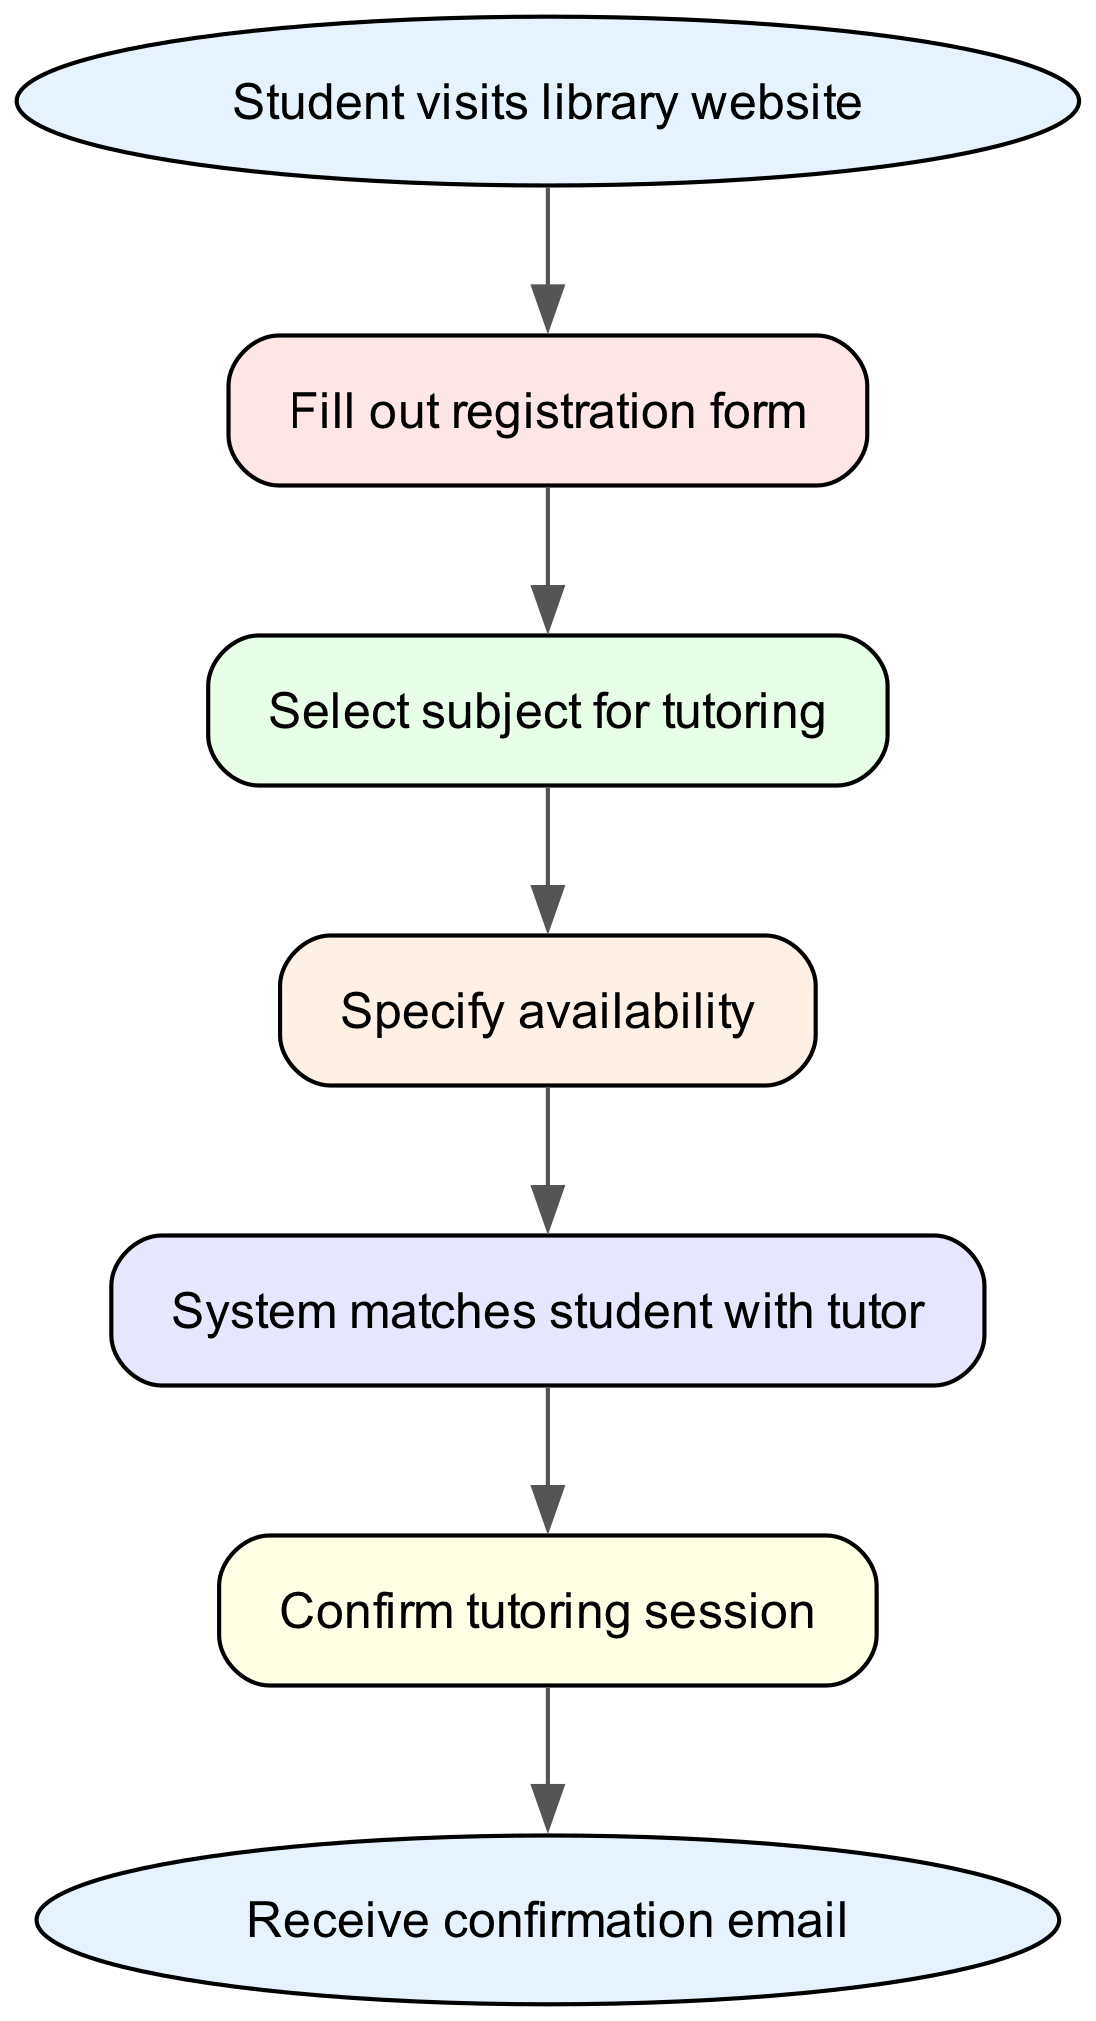What is the first step in the flowchart? The first step, represented by the node labeled "Student visits library website," indicates where the process begins.
Answer: Student visits library website How many nodes are present in the diagram? Counting all the unique nodes, there are 7 nodes in total, including the start and end nodes.
Answer: 7 What does the student do after filling out the registration form? The diagram shows that after the student fills out the registration form, the next step is to select a subject for tutoring.
Answer: Select subject for tutoring Which step comes immediately after specifying availability? According to the flowchart, after specifying availability, the system matches the student with a tutor.
Answer: System matches student with tutor What is the output of the process? The final output of the process is indicated by the node labeled "Receive confirmation email."
Answer: Receive confirmation email Which nodes are linked directly by the edge with the ID "edge4"? The edge with the ID "edge4" links the nodes "Specify availability" and "System matches student with tutor."
Answer: Specify availability and System matches student with tutor How many edges are there in the flowchart? By counting the connections or edges between the nodes, there are a total of 6 edges in the diagram.
Answer: 6 What four actions must the student take before receiving a confirmation email? The student must visit the library website, fill out the registration form, select a subject, and specify availability before receiving a confirmation email.
Answer: Visit website, fill form, select subject, specify availability 